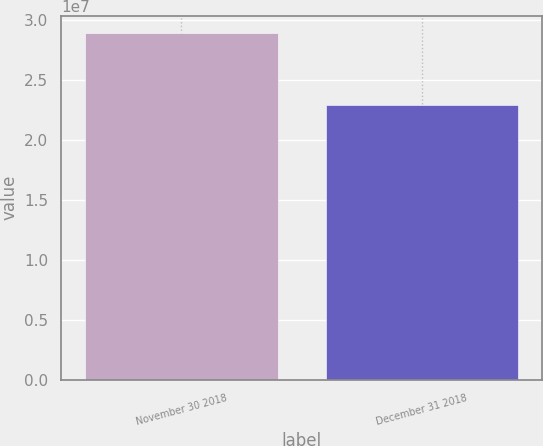Convert chart to OTSL. <chart><loc_0><loc_0><loc_500><loc_500><bar_chart><fcel>November 30 2018<fcel>December 31 2018<nl><fcel>2.88932e+07<fcel>2.293e+07<nl></chart> 